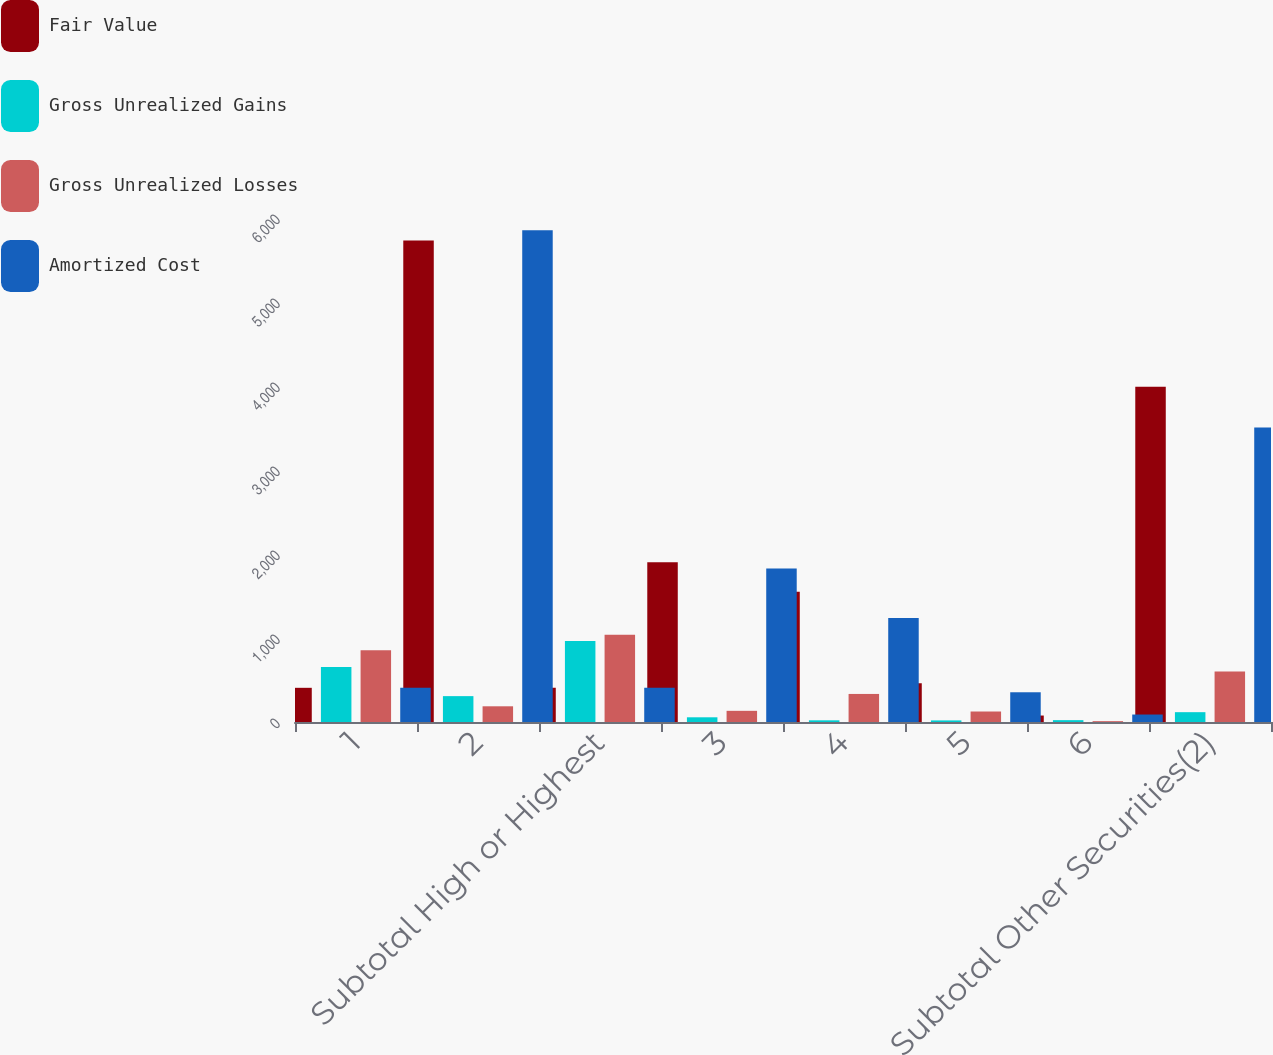Convert chart to OTSL. <chart><loc_0><loc_0><loc_500><loc_500><stacked_bar_chart><ecel><fcel>1<fcel>2<fcel>Subtotal High or Highest<fcel>3<fcel>4<fcel>5<fcel>6<fcel>Subtotal Other Securities(2)<nl><fcel>Fair Value<fcel>407<fcel>5732<fcel>407<fcel>1903<fcel>1552<fcel>460<fcel>77<fcel>3992<nl><fcel>Gross Unrealized Gains<fcel>656<fcel>308<fcel>964<fcel>56<fcel>20<fcel>19<fcel>22<fcel>117<nl><fcel>Gross Unrealized Losses<fcel>853<fcel>187<fcel>1040<fcel>133<fcel>334<fcel>125<fcel>10<fcel>602<nl><fcel>Amortized Cost<fcel>407<fcel>5853<fcel>407<fcel>1826<fcel>1238<fcel>354<fcel>89<fcel>3507<nl></chart> 